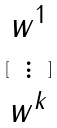<formula> <loc_0><loc_0><loc_500><loc_500>[ \begin{matrix} w ^ { 1 } \\ \vdots \\ w ^ { k } \end{matrix} ]</formula> 